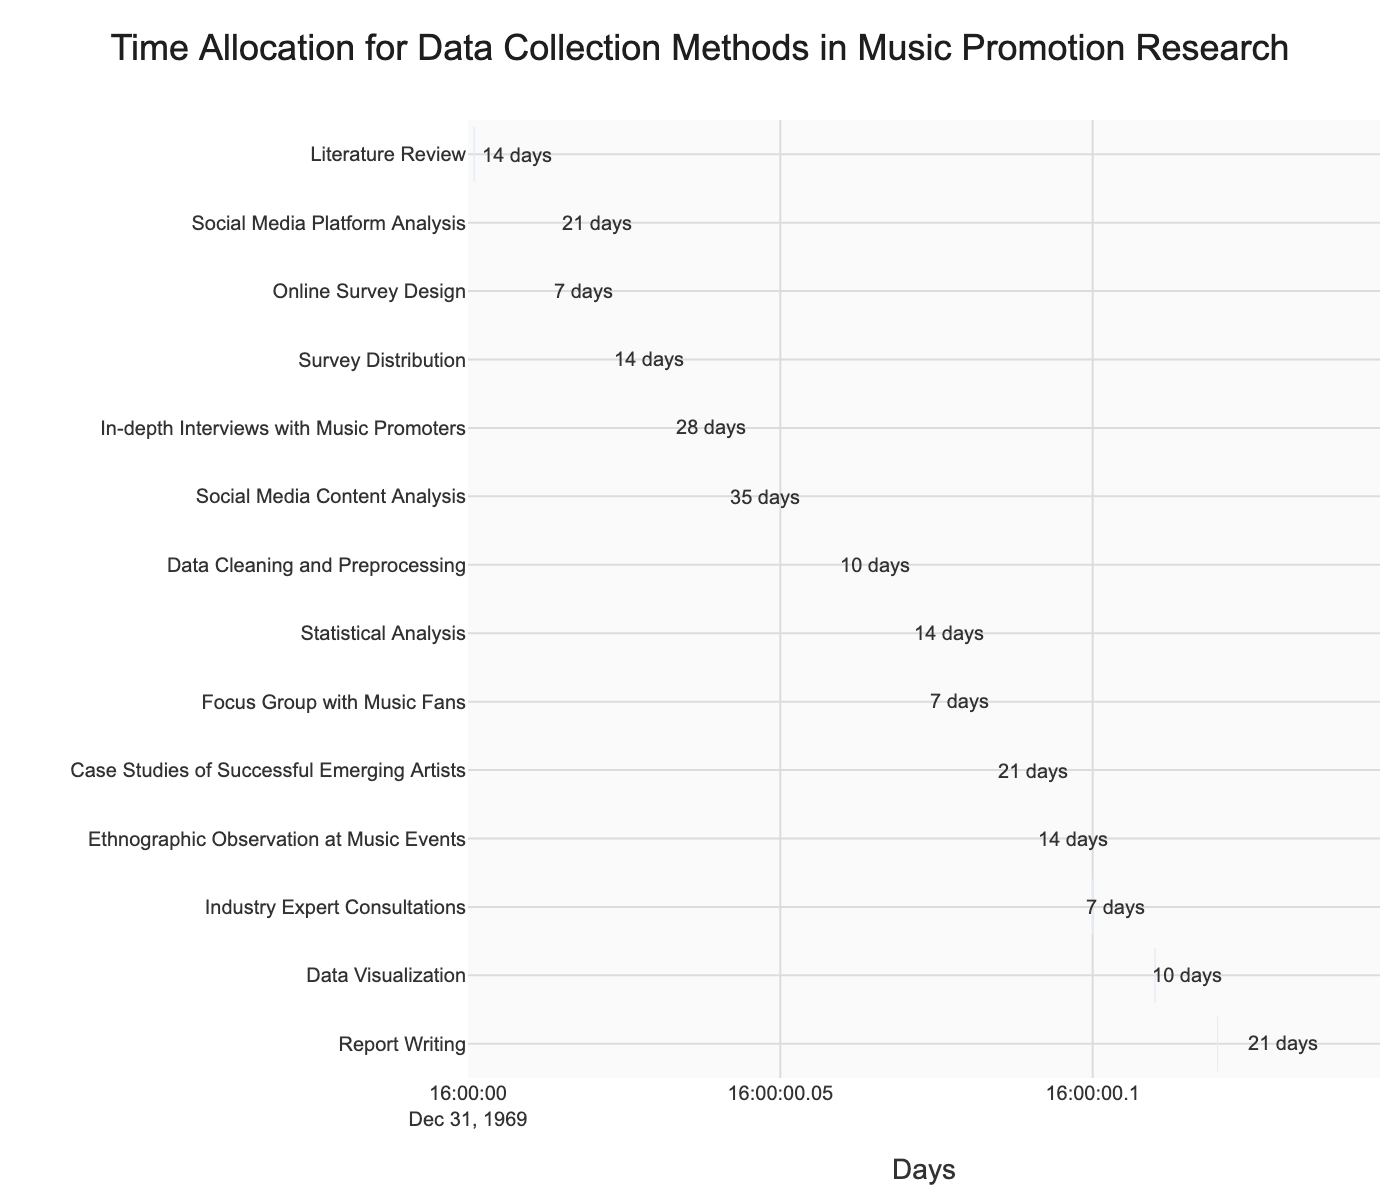what is the duration of the 'Ethnographic Observation at Music Events' task? The 'Ethnographic Observation at Music Events' task starts on day 90 and ends on day 104, which implies it lasts for 14 days.
Answer: 14 days On what day does the 'Report Writing' task start? Reading the 'Report Writing' task bar, we can see it begins at day 120.
Answer: Day 120 How long does the 'Data Cleaning and Preprocessing' task last? According to the bar representing 'Data Cleaning and Preprocessing', the task has a duration of 10 days.
Answer: 10 days Which task has the longest duration? Checking all bars, 'Social Media Content Analysis' runs for the longest duration, spanning 35 days from day 30 to day 65.
Answer: Social Media Content Analysis How many tasks start on or before day 25? We need to count tasks with their start day on or before day 25: 'Literature Review' (Day 1), 'Social Media Platform Analysis' (Day 10), 'Online Survey Design' (Day 15), 'Survey Distribution' (Day 22), and 'In-depth Interviews with Music Promoters' (Day 25).
Answer: 5 tasks What is the duration difference between 'Statistical Analysis' and 'Focus Group with Music Fans'? 'Statistical Analysis' lasts for 14 days, ‘Focus Group with Music Fans’ lasts for 7 days. Therefore, the duration difference is 14 - 7 = 7 days.
Answer: 7 days Which two tasks overlap in their time of performance? Observing overlapping bars in the Gantt chart, 'Survey Distribution' and 'In-depth Interviews with Music Promoters' both overlap between days 25 and 36.
Answer: Survey Distribution and In-depth Interviews with Music Promoters What is the average duration of all the tasks? Total duration of tasks: 14 (Literature Review) + 21 (Social Media Platform Analysis) + 7 (Online Survey Design) + 14 (Survey Distribution) + 28 (In-depth Interviews with Music Promoters) + 35 (Social Media Content Analysis) + 10 (Data Cleaning and Preprocessing) + 14 (Statistical Analysis) + 7 (Focus Group with Music Fans) + 21 (Case Studies of Successful Emerging Artists) + 14 (Ethnographic Observation at Music Events) + 7 (Industry Expert Consultations) + 10 (Data Visualization) + 21 (Report Writing) = 223 days. Average = Total Duration / Number of tasks = 223 / 14 ≈ 15.93 days.
Answer: ≈ 15.93 days When do the 'Literature Review' and 'Report Writing' tasks each finish? The 'Literature Review' task ends on day 15 (1 + 14). The 'Report Writing' task finishes on day 141 (120 + 21).
Answer: Day 15 and Day 141 Is the 'Industry Expert Consultations' task shorter than 'Focus Group with Music Fans'? 'Industry Expert Consultations' lasts for 7 days, which is the same as 'Focus Group with Music Fans'. They are equal in duration.
Answer: No, they are equal 